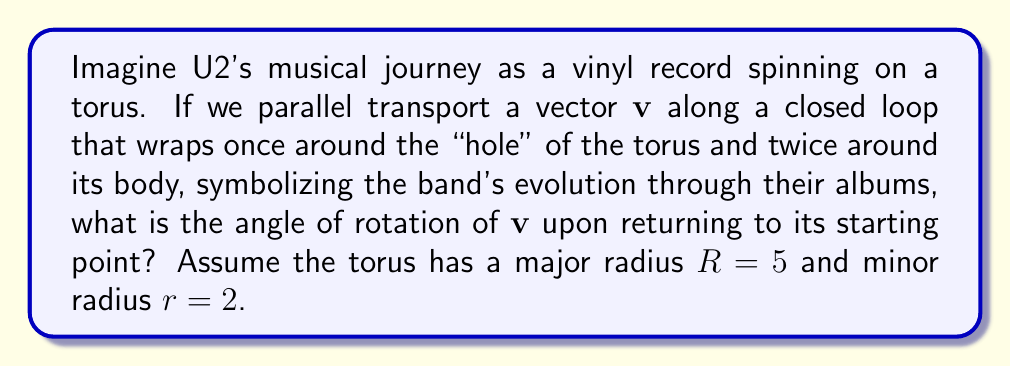Could you help me with this problem? Let's break this down step-by-step, like tracking U2's discography:

1) On a torus, parallel transport of a vector along a closed loop results in a rotation. The angle of rotation depends on the solid angle enclosed by the loop.

2) The solid angle $\Omega$ enclosed by a loop on a torus is given by:

   $$\Omega = 2\pi n_\phi (1 - \cos\theta)$$

   Where $n_\phi$ is the number of times the loop wraps around the body of the torus, and $\theta$ is the angle between the center of the tube and the center of the torus.

3) We're told the loop wraps twice around the body, so $n_\phi = 2$.

4) To find $\cos\theta$, we use the ratio of the radii:

   $$\cos\theta = \frac{r}{R} = \frac{2}{5}$$

5) Now we can calculate the solid angle:

   $$\Omega = 2\pi \cdot 2 \cdot (1 - \frac{2}{5}) = \frac{12\pi}{5}$$

6) The angle of rotation $\alpha$ is related to the solid angle by:

   $$\alpha = -\frac{\Omega}{2\pi} \cdot 2\pi = -\Omega = -\frac{12\pi}{5}$$

7) Therefore, the vector will rotate by an angle of $-\frac{12\pi}{5}$ radians, or $-432°$.

[asy]
import geometry;

size(200);
real R = 5;
real r = 2;
path3 p = circle(c=(R,0,0), r=r, normal=(0,0,1));
revolution torus = revolution(p, Z);
draw(surface(torus), lightgray);
draw(circle((R,0,0),r), blue);
draw(circle((0,0,0),R), red);
label("R", (R/2,0,0), S);
label("r", (R+r/2,0,0), E);
[/asy]
Answer: $-\frac{12\pi}{5}$ radians or $-432°$ 